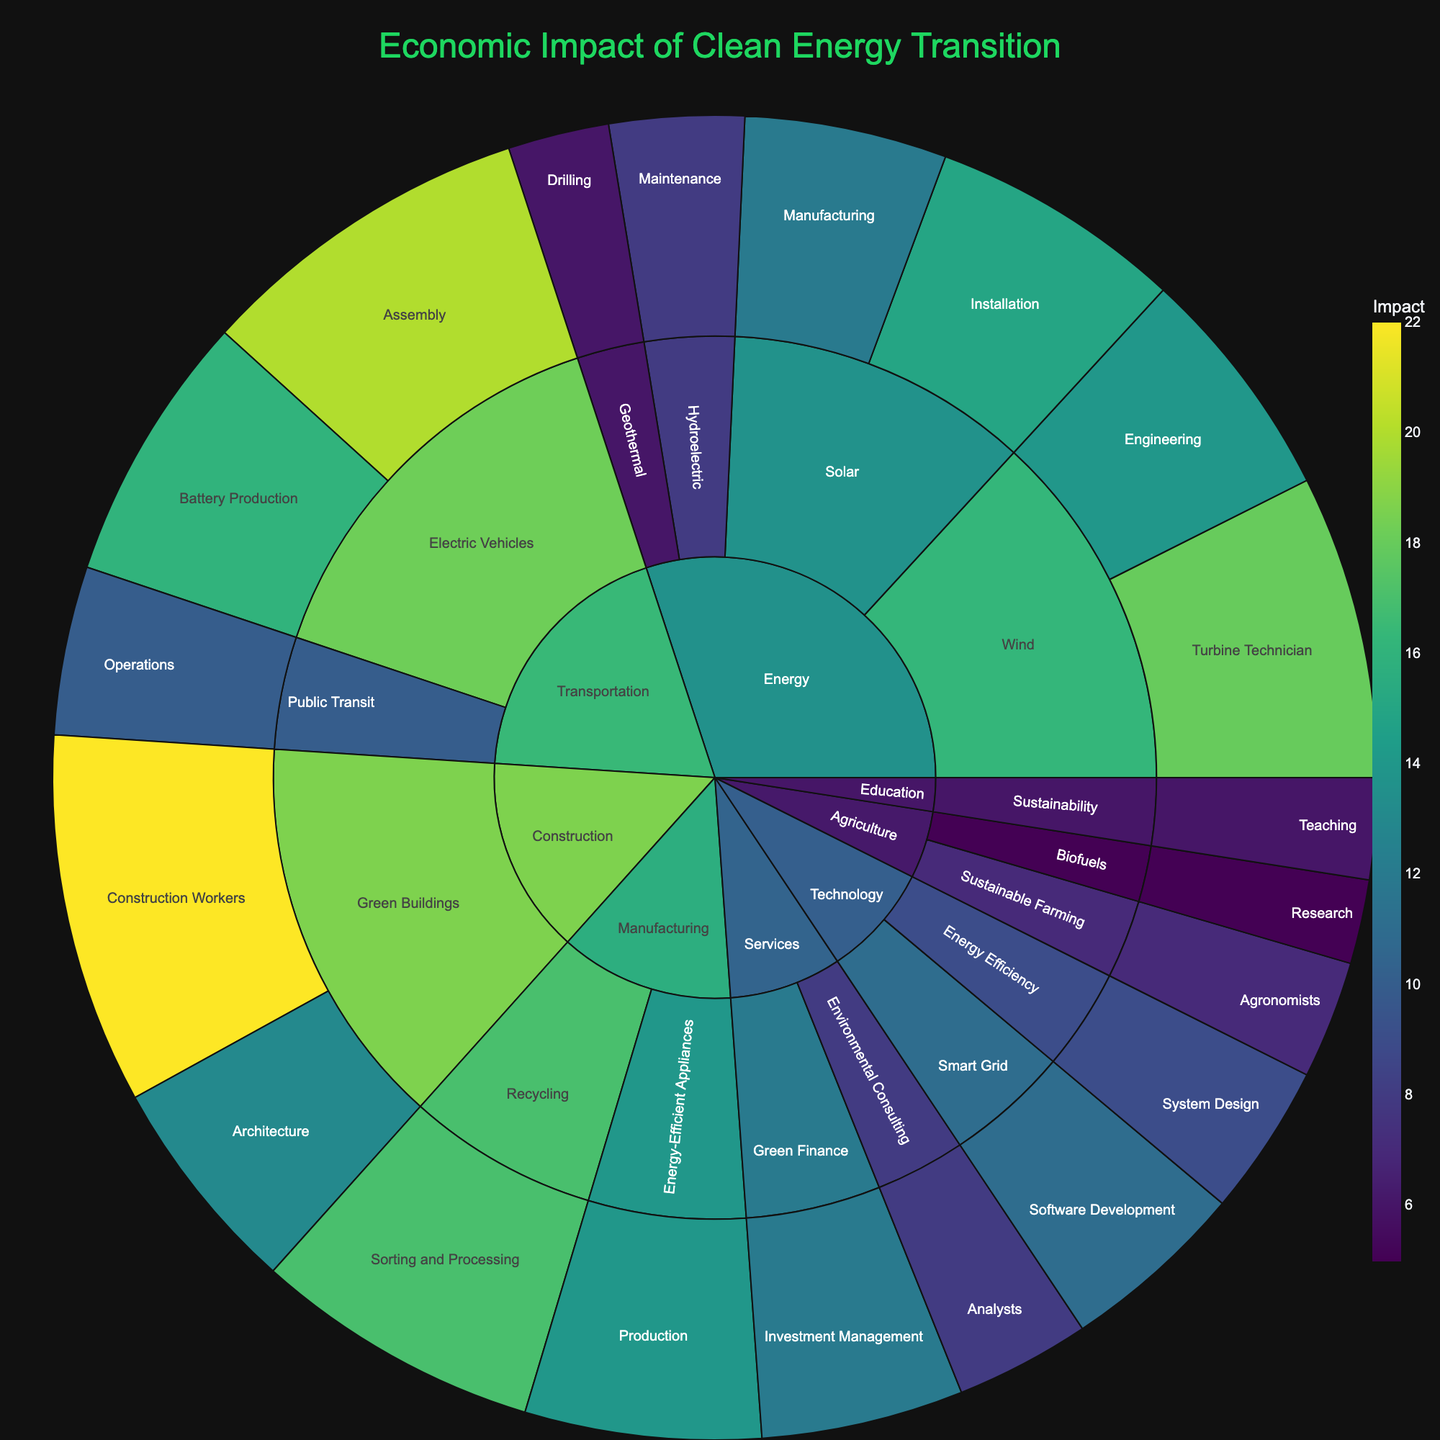What is the title of the figure? The title is often displayed at the top of the figure and is usually written in a larger font size. Observing the figure, one can see the title as the largest text, centered at the top.
Answer: Economic Impact of Clean Energy Transition Which sector has the highest economic impact in Installation jobs? To answer this, look at the "Energy" sector, then the "Solar" industry, and finally the "Installation" job category to find the associated impact value.
Answer: Energy (Solar) How many job categories are there under the "Technology" sector? Identify the "Technology" sector, follow the tree to see all industries, and count all distinct job categories under this sector.
Answer: 2 What is the total economic impact of all job categories in the "Transportation" sector? Sum the impact values for "Assembly" and "Battery Production" in Electric Vehicles and "Operations" in Public Transit. The total is 20 + 16 + 10.
Answer: 46 What is the difference in economic impact between "Construction Workers" in Green Buildings and "Analysts" in Environmental Consulting? Find "Construction Workers" and "Analysts" impacts, which are 22 and 8 respectively. Subtract the smaller from the larger value (22 - 8).
Answer: 14 Which job category in the "Manufacturing" sector has the highest impact? Focus on the "Manufacturing" sector, then compare the impacts for "Sorting and Processing" and "Production." "Sorting and Processing" has higher impact.
Answer: Sorting and Processing What is the average economic impact of all job categories in the "Energy" sector? List impacts in "Energy" sector: 15 (Installation), 12 (Manufacturing), 18 (Turbine Technician), 14 (Engineering), 8 (Maintenance), and 6 (Drilling). Sum these values and divide by the number of categories (15+12+18+14+8+6)/6.
Answer: 12.17 Which sector has more job categories, "Agriculture" or "Education"? Identify all job categories under each sector by following the hierarchical paths for "Agriculture" and "Education", and then compare the counts. "Agriculture" has 2 (Agronomists, Research), "Education" has 1 (Teaching).
Answer: Agriculture Which job category contributes the least impact in the "Technology" sector? In the "Technology" sector, compare the impact values of "Software Development" and "System Design." The lowest impact is 9 for "System Design."
Answer: System Design 